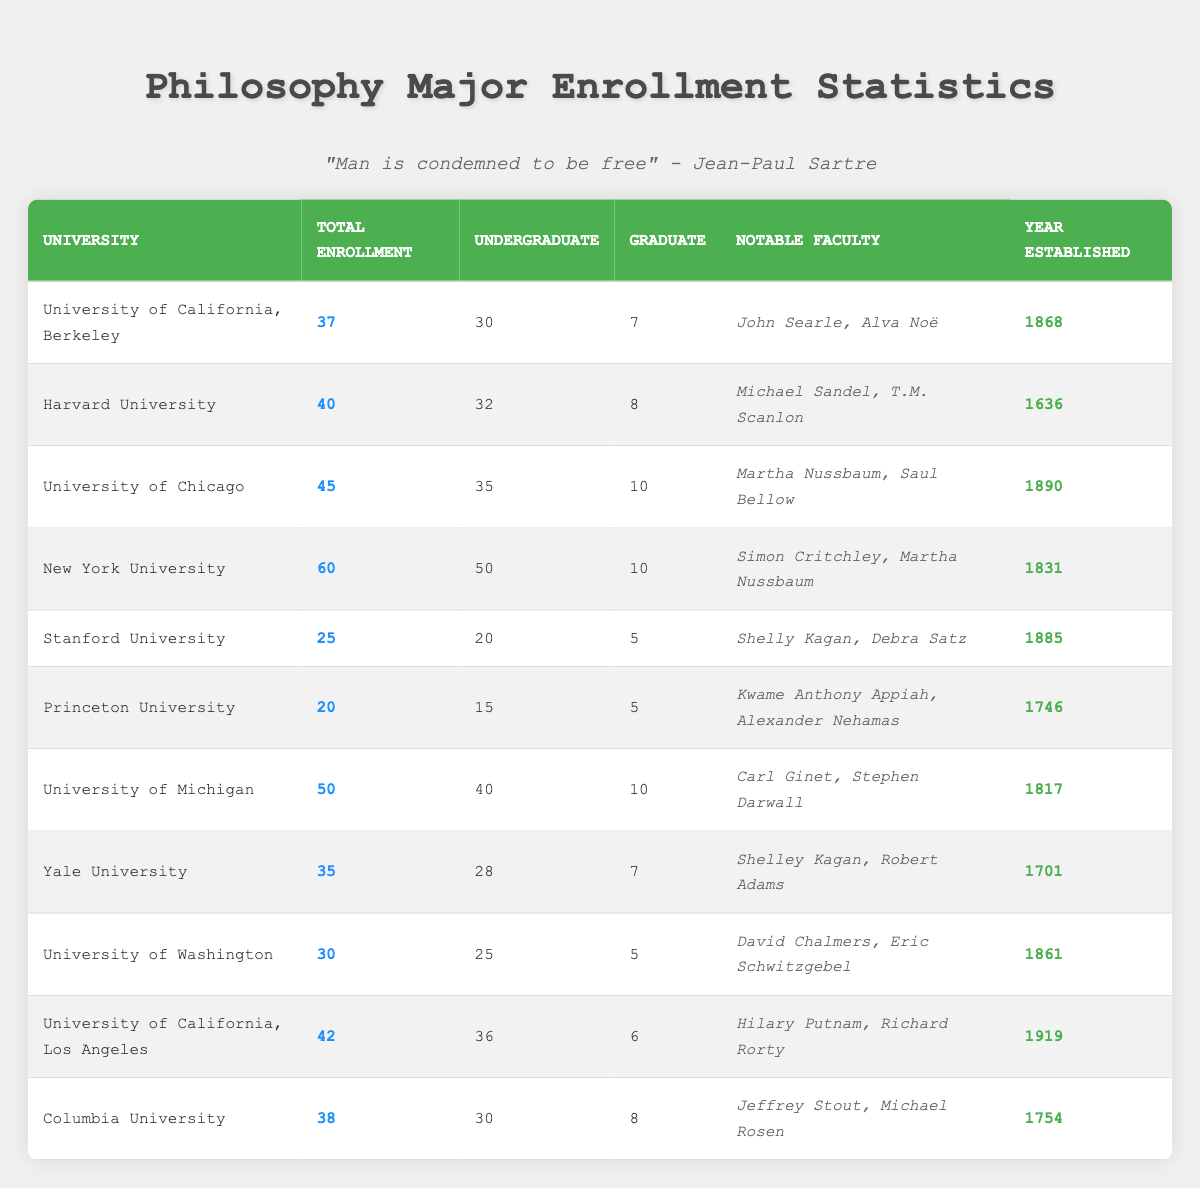What university has the highest total enrollment of philosophy majors? The table lists the enrollment for each university. By examining the "Total Enrollment" column, New York University has the highest number at 60.
Answer: New York University How many philosophy majors are there at Stanford University? Looking at the "Total Enrollment" column for Stanford University, the number is listed as 25.
Answer: 25 Which university has the most graduate philosophy students? By comparing the "Graduate Enrollment" column, the University of Chicago has 10 graduate students, which is the highest.
Answer: University of Chicago What is the average undergraduate enrollment across all listed universities? Adding the undergraduate enrollments: 30 + 32 + 35 + 50 + 20 + 15 + 40 + 28 + 25 + 36 + 30 =  305. There are 11 universities, so the average is 305/11 ≈ 27.73.
Answer: Approximately 27.73 How many more undergraduate students does Harvard University have compared to Princeton University? Harvard has 32 undergraduate students and Princeton has 15. Subtracting these numbers: 32 - 15 = 17.
Answer: 17 Are there more philosophy majors at Yale University than at Stanford University? Yale has a total enrollment of 35, while Stanford has 25. Since 35 > 25, the answer is yes.
Answer: Yes Which universities have notable faculty members named Martha Nussbaum? Upon reviewing the "Notable Faculty" column, both the University of Chicago and New York University list Martha Nussbaum.
Answer: University of Chicago and New York University What is the total enrollment of philosophy majors in universities established before 1800? The relevant universities are Harvard (40), Princeton (20), Yale (35), and Columbia (38). Adding these gives: 40 + 20 + 35 + 38 = 133.
Answer: 133 What percentage of students in the University of California, Berkeley are undergraduates? The total enrollment at UC Berkeley is 37, with 30 undergraduates. The percentage is calculated as (30/37) * 100 ≈ 81.08%.
Answer: Approximately 81.08% How does the total enrollment at the University of Washington compare to that of Stanford University? The University of Washington has 30 students, while Stanford has 25. Since 30 > 25, it's greater.
Answer: Greater 